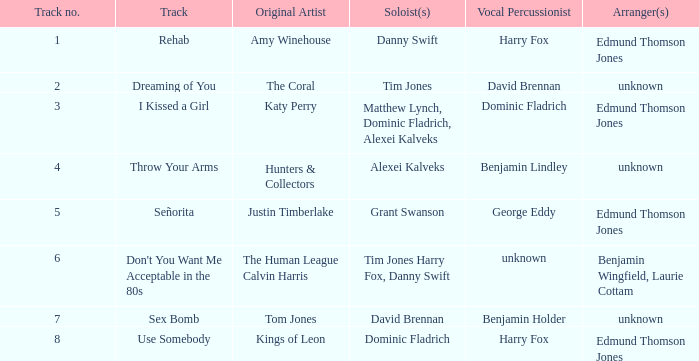Who is the percussionist for The Coral? David Brennan. 